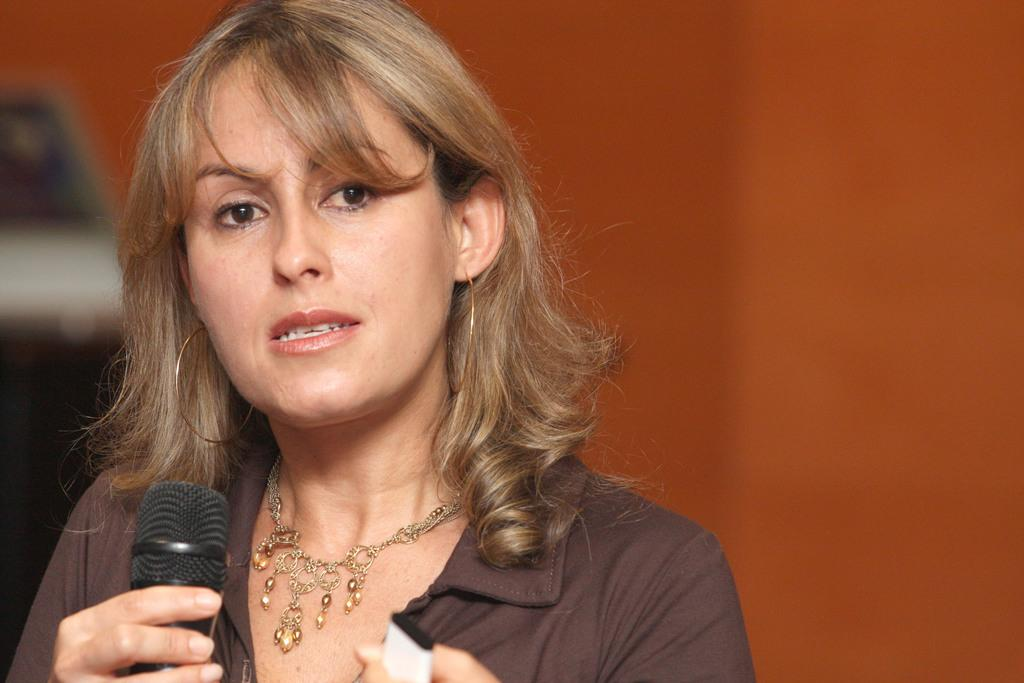What is the main subject of the image? The main subject of the image is a woman. What is the woman holding in the image? The woman is holding a microphone. What is the woman wearing in the image? The woman is wearing a brown dress and ornaments. What type of company is the woman representing in the image? There is no indication in the image of the woman representing any specific company. Can you see any rats or knives in the image? No, there are no rats or knives present in the image. 